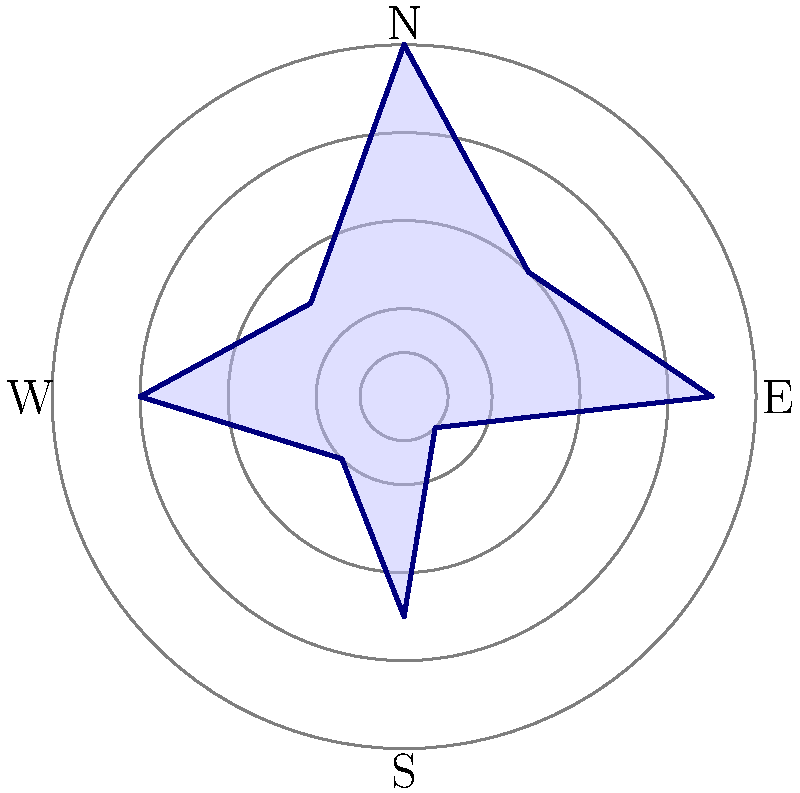As the owner of a legendary metal club, you've decided to analyze the intensity and direction of headbanging movements during a concert. The polar graph above represents the average headbanging intensity (radius) in different directions (angles) throughout the night. What is the direction (in degrees) where the headbanging intensity reaches its maximum, and what is this maximum intensity value? To find the direction and maximum intensity of headbanging, we need to analyze the polar graph:

1. The graph shows 8 data points, representing different directions and intensities.
2. Each concentric circle represents an intensity level, with the outermost circle at 8 and inner circles at 6, 4, and 2.
3. The angles are divided into 45° intervals (π/4 radians).
4. We need to identify the point farthest from the center, which represents the maximum intensity.

Analyzing the data points clockwise from the positive x-axis (0°):
- 0°: r ≈ 7
- 45°: r ≈ 4
- 90°: r ≈ 8 (maximum)
- 135°: r ≈ 3
- 180°: r ≈ 6
- 225°: r ≈ 2
- 270°: r ≈ 5
- 315°: r ≈ 1

The maximum intensity is at 90° (East direction) with a value of 8.
Answer: 90°, 8 